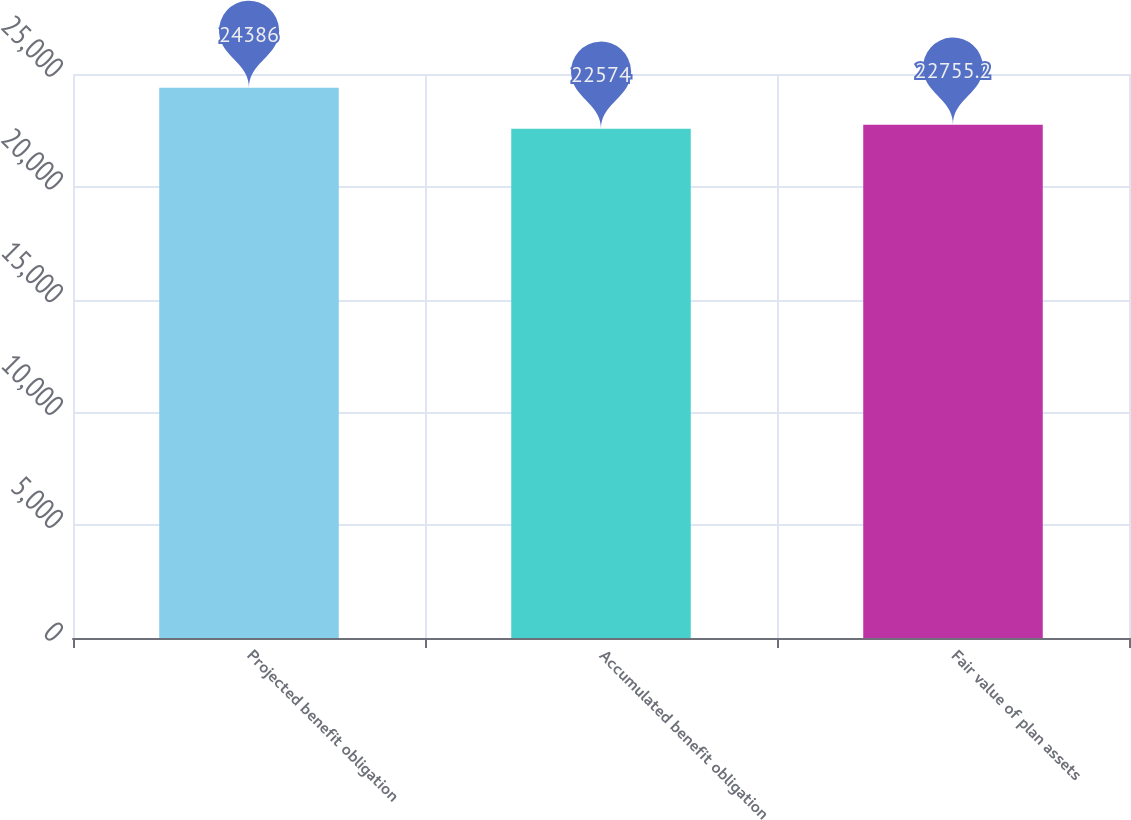Convert chart to OTSL. <chart><loc_0><loc_0><loc_500><loc_500><bar_chart><fcel>Projected benefit obligation<fcel>Accumulated benefit obligation<fcel>Fair value of plan assets<nl><fcel>24386<fcel>22574<fcel>22755.2<nl></chart> 